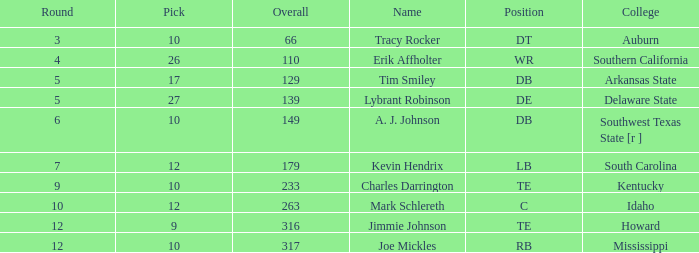What is the total of overall for "tim smiley" when round is below 5? None. 